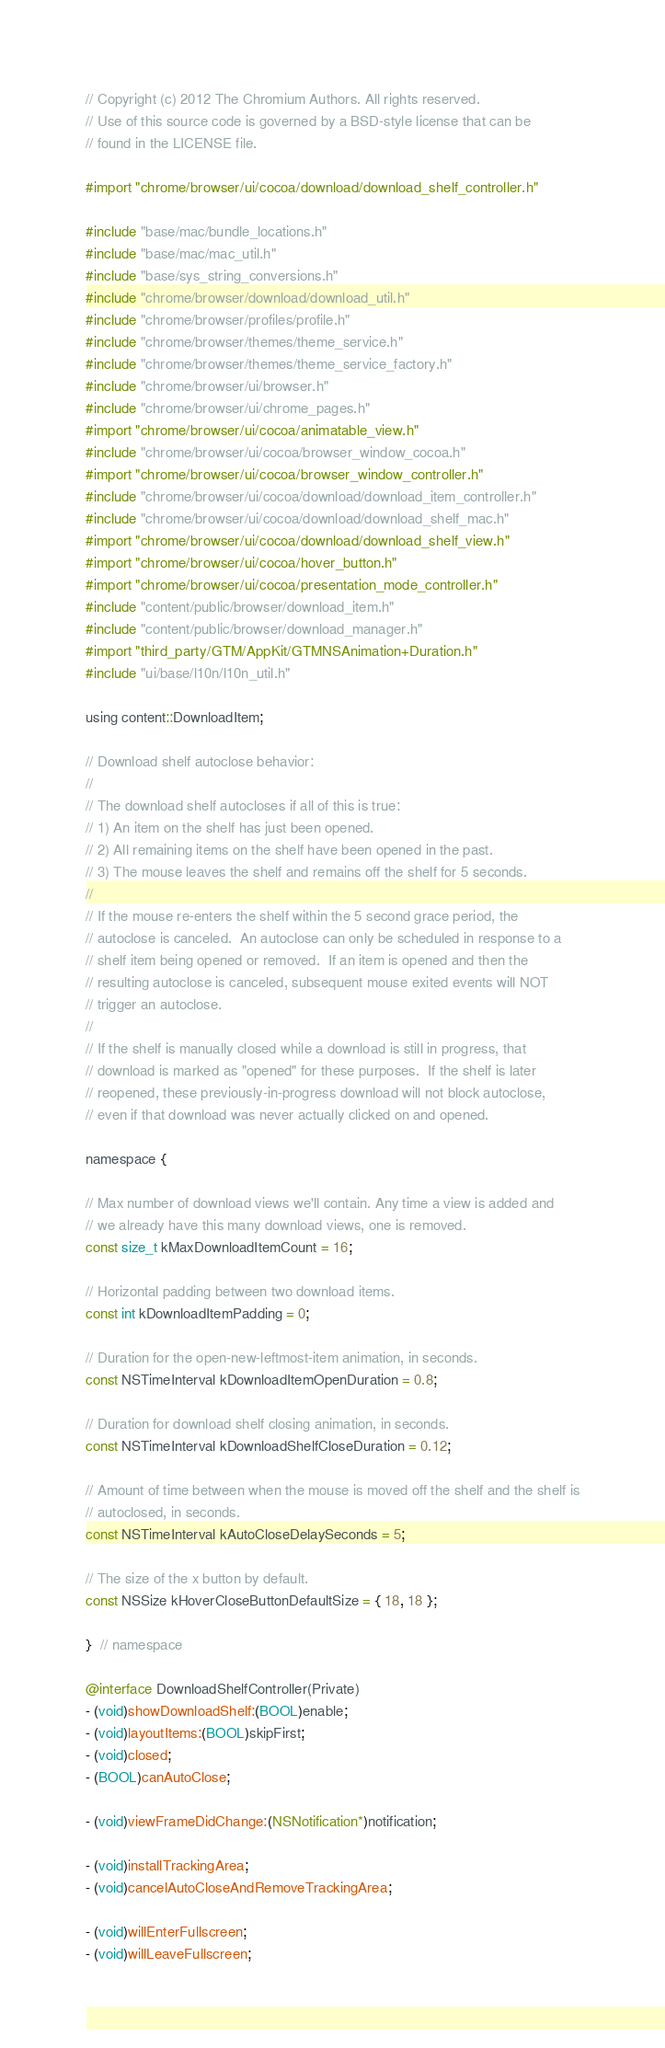<code> <loc_0><loc_0><loc_500><loc_500><_ObjectiveC_>// Copyright (c) 2012 The Chromium Authors. All rights reserved.
// Use of this source code is governed by a BSD-style license that can be
// found in the LICENSE file.

#import "chrome/browser/ui/cocoa/download/download_shelf_controller.h"

#include "base/mac/bundle_locations.h"
#include "base/mac/mac_util.h"
#include "base/sys_string_conversions.h"
#include "chrome/browser/download/download_util.h"
#include "chrome/browser/profiles/profile.h"
#include "chrome/browser/themes/theme_service.h"
#include "chrome/browser/themes/theme_service_factory.h"
#include "chrome/browser/ui/browser.h"
#include "chrome/browser/ui/chrome_pages.h"
#import "chrome/browser/ui/cocoa/animatable_view.h"
#include "chrome/browser/ui/cocoa/browser_window_cocoa.h"
#import "chrome/browser/ui/cocoa/browser_window_controller.h"
#include "chrome/browser/ui/cocoa/download/download_item_controller.h"
#include "chrome/browser/ui/cocoa/download/download_shelf_mac.h"
#import "chrome/browser/ui/cocoa/download/download_shelf_view.h"
#import "chrome/browser/ui/cocoa/hover_button.h"
#import "chrome/browser/ui/cocoa/presentation_mode_controller.h"
#include "content/public/browser/download_item.h"
#include "content/public/browser/download_manager.h"
#import "third_party/GTM/AppKit/GTMNSAnimation+Duration.h"
#include "ui/base/l10n/l10n_util.h"

using content::DownloadItem;

// Download shelf autoclose behavior:
//
// The download shelf autocloses if all of this is true:
// 1) An item on the shelf has just been opened.
// 2) All remaining items on the shelf have been opened in the past.
// 3) The mouse leaves the shelf and remains off the shelf for 5 seconds.
//
// If the mouse re-enters the shelf within the 5 second grace period, the
// autoclose is canceled.  An autoclose can only be scheduled in response to a
// shelf item being opened or removed.  If an item is opened and then the
// resulting autoclose is canceled, subsequent mouse exited events will NOT
// trigger an autoclose.
//
// If the shelf is manually closed while a download is still in progress, that
// download is marked as "opened" for these purposes.  If the shelf is later
// reopened, these previously-in-progress download will not block autoclose,
// even if that download was never actually clicked on and opened.

namespace {

// Max number of download views we'll contain. Any time a view is added and
// we already have this many download views, one is removed.
const size_t kMaxDownloadItemCount = 16;

// Horizontal padding between two download items.
const int kDownloadItemPadding = 0;

// Duration for the open-new-leftmost-item animation, in seconds.
const NSTimeInterval kDownloadItemOpenDuration = 0.8;

// Duration for download shelf closing animation, in seconds.
const NSTimeInterval kDownloadShelfCloseDuration = 0.12;

// Amount of time between when the mouse is moved off the shelf and the shelf is
// autoclosed, in seconds.
const NSTimeInterval kAutoCloseDelaySeconds = 5;

// The size of the x button by default.
const NSSize kHoverCloseButtonDefaultSize = { 18, 18 };

}  // namespace

@interface DownloadShelfController(Private)
- (void)showDownloadShelf:(BOOL)enable;
- (void)layoutItems:(BOOL)skipFirst;
- (void)closed;
- (BOOL)canAutoClose;

- (void)viewFrameDidChange:(NSNotification*)notification;

- (void)installTrackingArea;
- (void)cancelAutoCloseAndRemoveTrackingArea;

- (void)willEnterFullscreen;
- (void)willLeaveFullscreen;</code> 